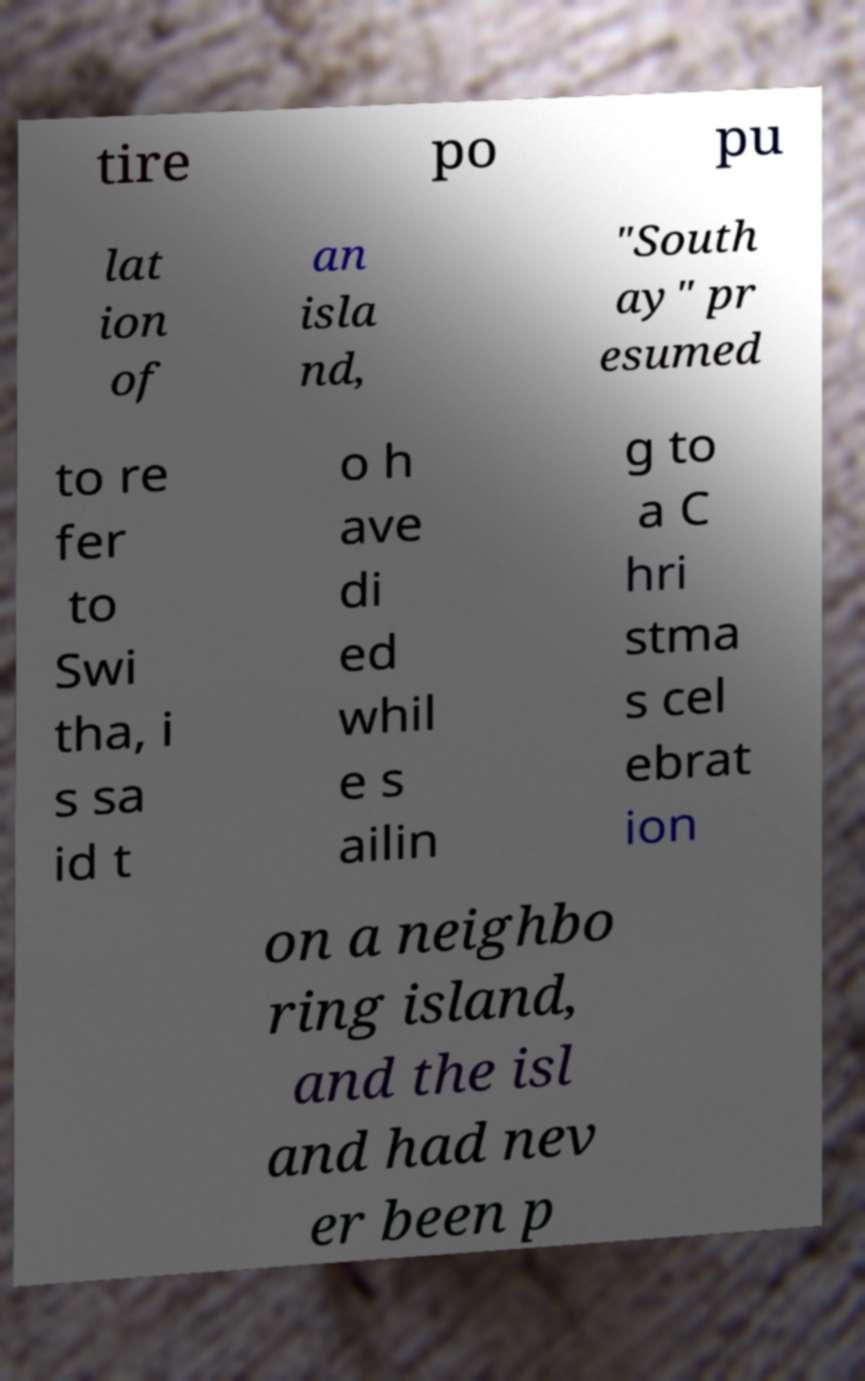What messages or text are displayed in this image? I need them in a readable, typed format. tire po pu lat ion of an isla nd, "South ay" pr esumed to re fer to Swi tha, i s sa id t o h ave di ed whil e s ailin g to a C hri stma s cel ebrat ion on a neighbo ring island, and the isl and had nev er been p 